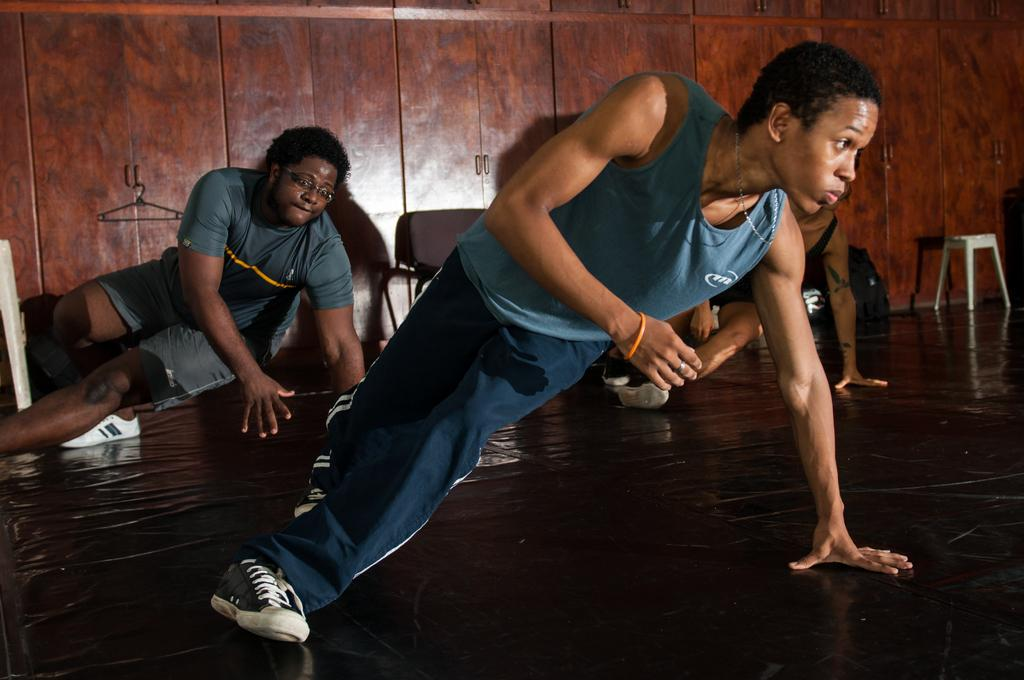What are the people in the image doing? There are persons dancing in the image. What can be seen in the background of the image? There is a stool in the background of the image. What colors are present on the objects in the image? There are objects with brown and white colors in the image. What type of furniture is present in the image? There are cupboards in the image. What type of fuel is being used by the persons dancing in the image? There is no mention of fuel or any energy source being used by the persons dancing in the image. --- Facts: 1. There is a person holding a book in the image. 2. The person is sitting on a chair. 3. There is a table in the image. 4. The table has a lamp on it. 5. There are books on the table. Absurd Topics: parrot, sand, bicycle Conversation: What is the person in the image holding? The person is holding a book in the image. What is the person sitting on? The person is sitting on a chair. What can be seen on the table in the image? There is a table in the image, and it has a lamp on it. What else is on the table besides the lamp? There are books on the table. Reasoning: Let's think step by step in order to produce the conversation. We start by identifying the main subject in the image, which is the person holding a book. Then, we describe the person's position and the presence of a chair. Next, we mention the table and its contents, including the lamp and additional books. Each question is designed to elicit a specific detail about the image that is known from the provided facts. Absurd Question/Answer: Can you tell me how many parrots are sitting on the bicycle in the image? There is no bicycle or parrot present in the image. 